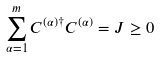Convert formula to latex. <formula><loc_0><loc_0><loc_500><loc_500>\sum _ { \alpha = 1 } ^ { m } C ^ { ( \alpha ) \dagger } C ^ { ( \alpha ) } = J \geq 0</formula> 